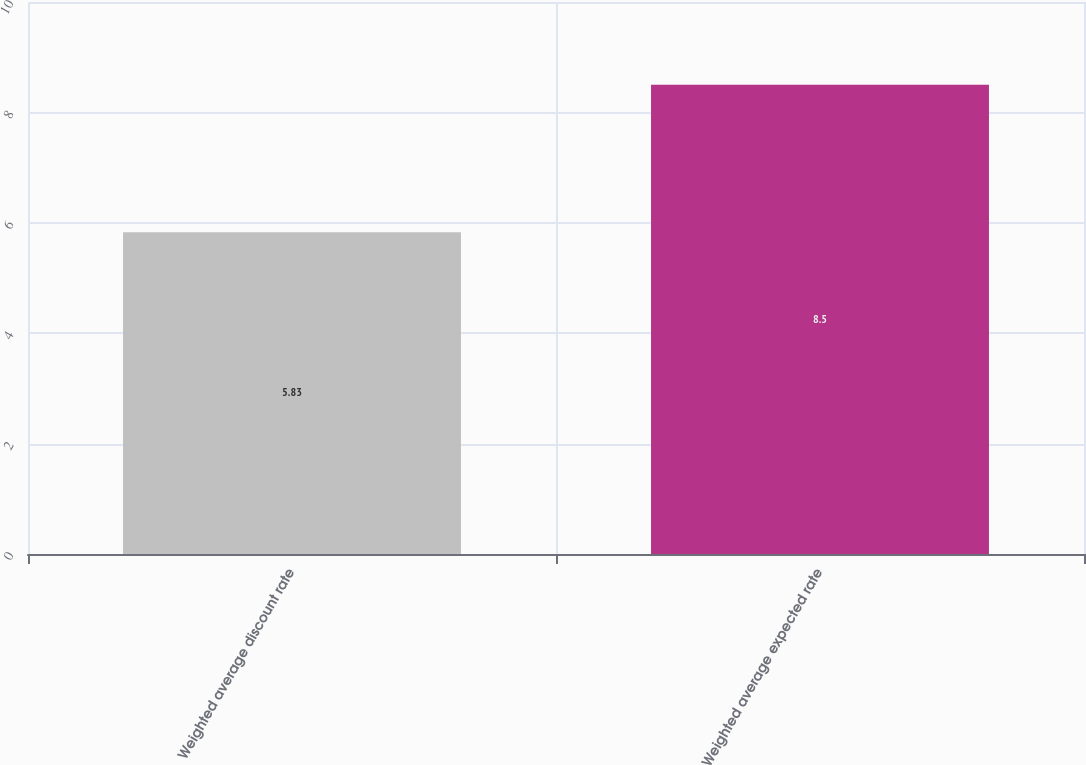Convert chart. <chart><loc_0><loc_0><loc_500><loc_500><bar_chart><fcel>Weighted average discount rate<fcel>Weighted average expected rate<nl><fcel>5.83<fcel>8.5<nl></chart> 